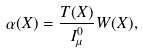<formula> <loc_0><loc_0><loc_500><loc_500>\alpha ( X ) = \frac { T ( X ) } { I _ { \mu } ^ { 0 } } W ( X ) ,</formula> 